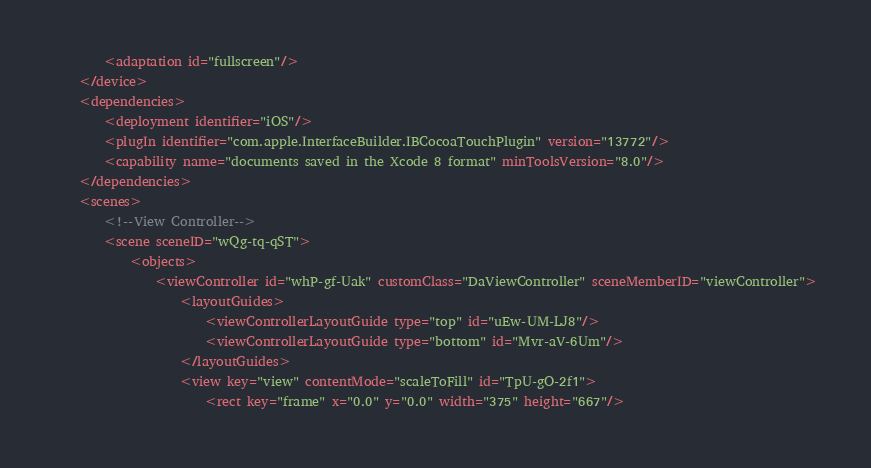<code> <loc_0><loc_0><loc_500><loc_500><_XML_>        <adaptation id="fullscreen"/>
    </device>
    <dependencies>
        <deployment identifier="iOS"/>
        <plugIn identifier="com.apple.InterfaceBuilder.IBCocoaTouchPlugin" version="13772"/>
        <capability name="documents saved in the Xcode 8 format" minToolsVersion="8.0"/>
    </dependencies>
    <scenes>
        <!--View Controller-->
        <scene sceneID="wQg-tq-qST">
            <objects>
                <viewController id="whP-gf-Uak" customClass="DaViewController" sceneMemberID="viewController">
                    <layoutGuides>
                        <viewControllerLayoutGuide type="top" id="uEw-UM-LJ8"/>
                        <viewControllerLayoutGuide type="bottom" id="Mvr-aV-6Um"/>
                    </layoutGuides>
                    <view key="view" contentMode="scaleToFill" id="TpU-gO-2f1">
                        <rect key="frame" x="0.0" y="0.0" width="375" height="667"/></code> 